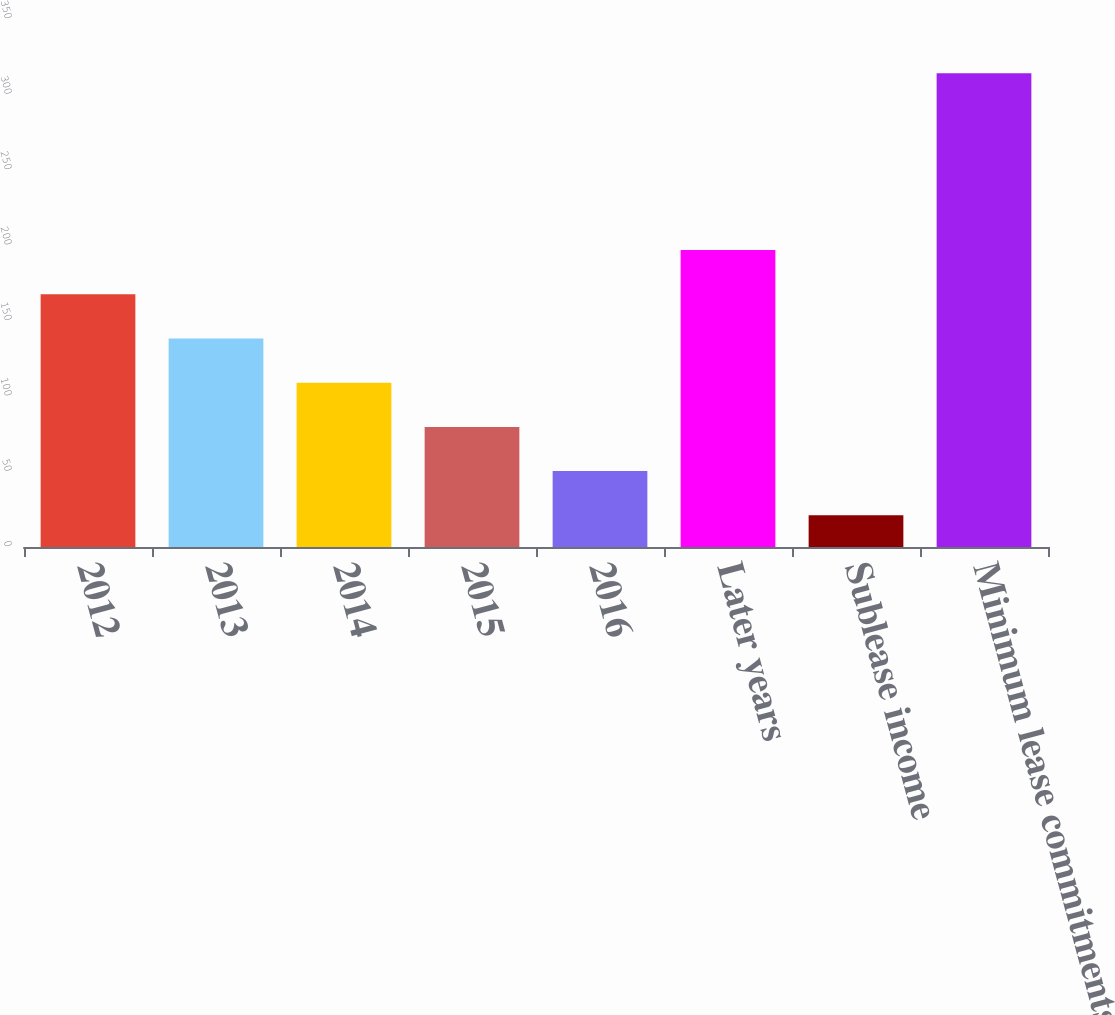Convert chart. <chart><loc_0><loc_0><loc_500><loc_500><bar_chart><fcel>2012<fcel>2013<fcel>2014<fcel>2015<fcel>2016<fcel>Later years<fcel>Sublease income<fcel>Minimum lease commitments<nl><fcel>167.5<fcel>138.2<fcel>108.9<fcel>79.6<fcel>50.3<fcel>196.8<fcel>21<fcel>314<nl></chart> 